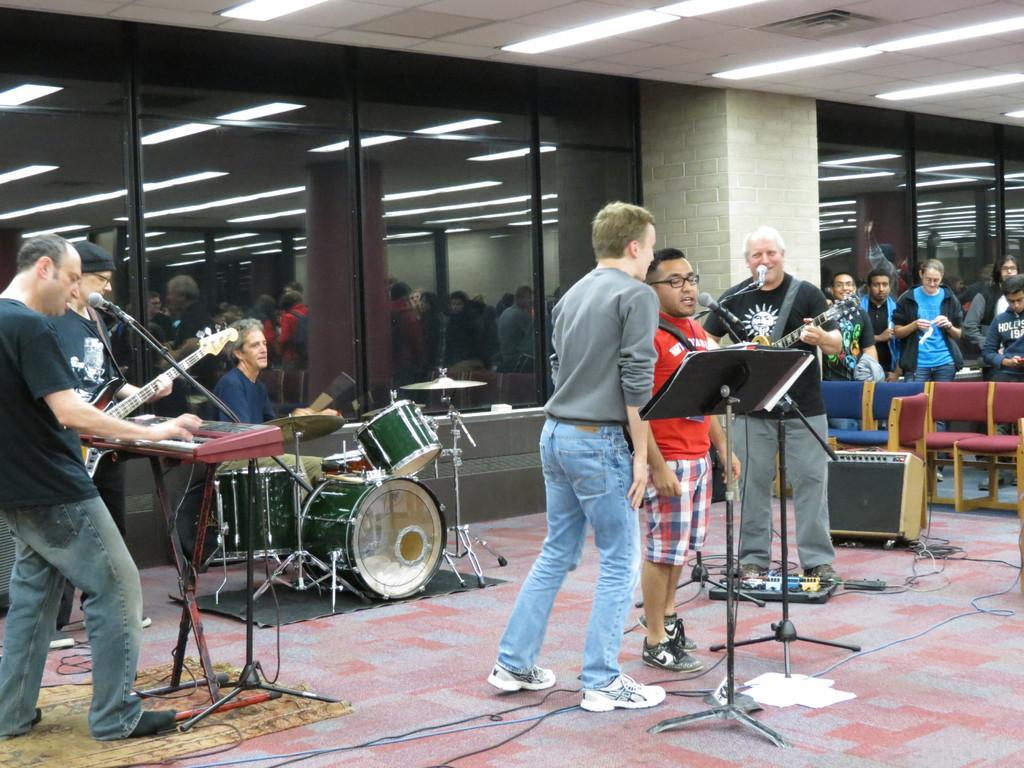In one or two sentences, can you explain what this image depicts? In this picture we can see a table where some are playing musical instruments such as guitar, piano, drums and here in middle two men are singing on mic and in the background we can see wall, some more persons looking at them, chairs, wires. 